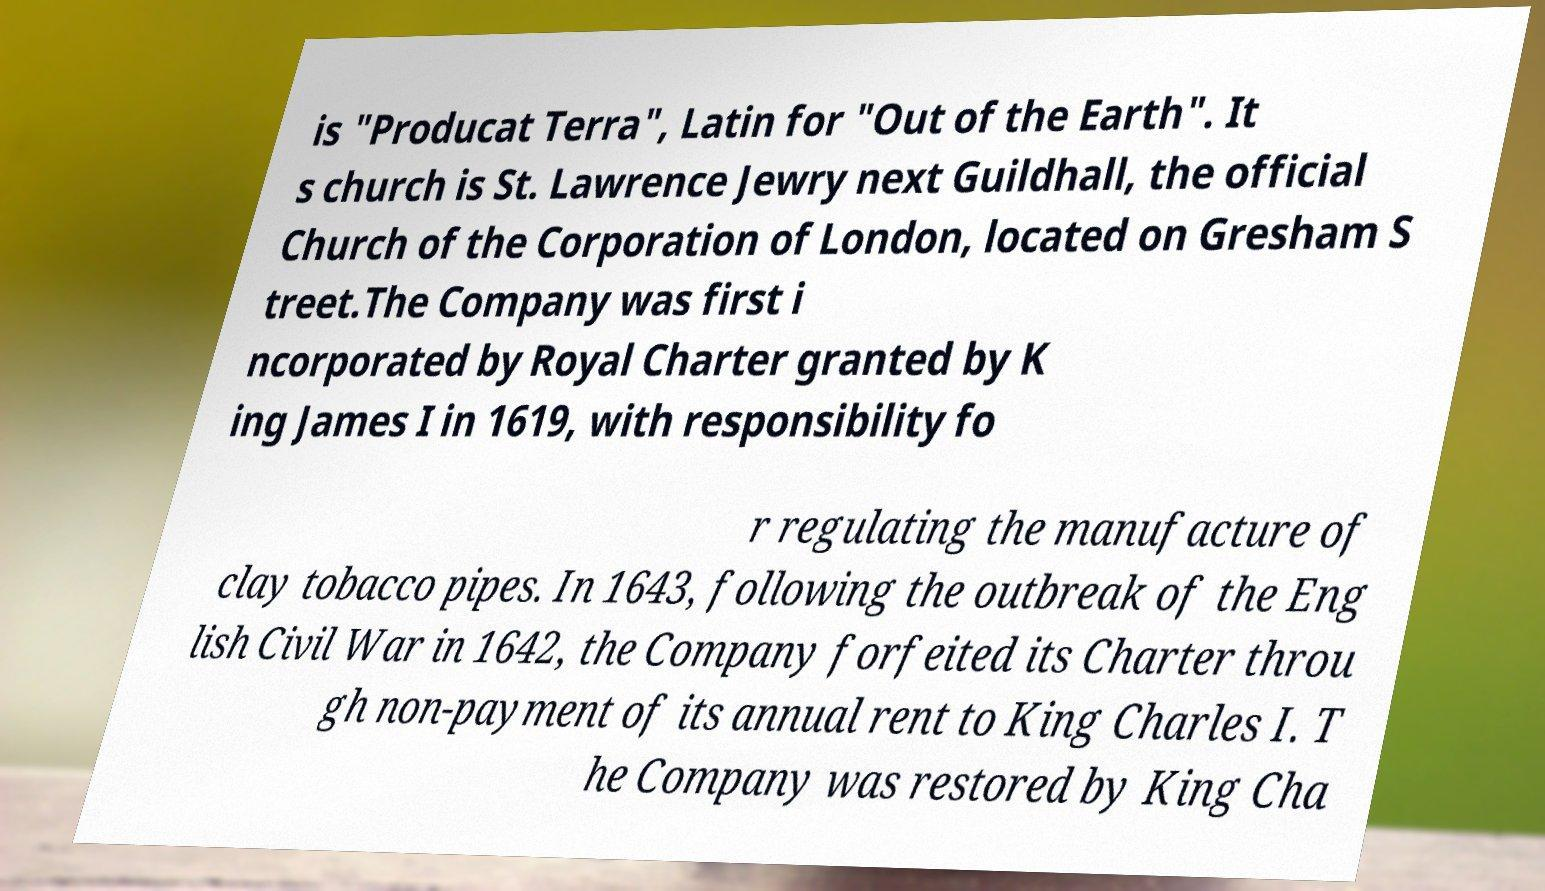Could you extract and type out the text from this image? is "Producat Terra", Latin for "Out of the Earth". It s church is St. Lawrence Jewry next Guildhall, the official Church of the Corporation of London, located on Gresham S treet.The Company was first i ncorporated by Royal Charter granted by K ing James I in 1619, with responsibility fo r regulating the manufacture of clay tobacco pipes. In 1643, following the outbreak of the Eng lish Civil War in 1642, the Company forfeited its Charter throu gh non-payment of its annual rent to King Charles I. T he Company was restored by King Cha 